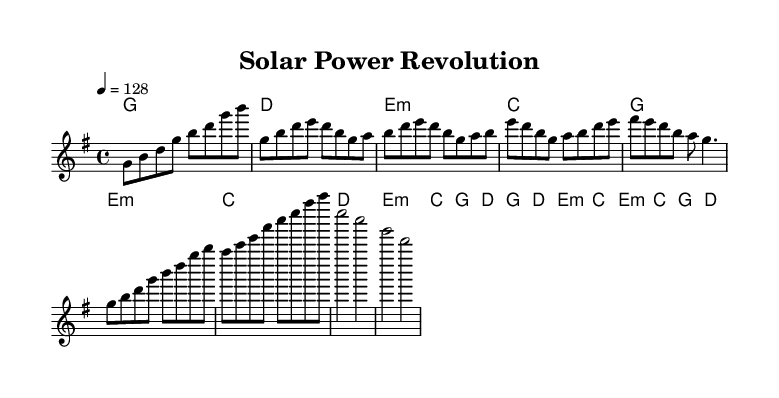What is the key signature of this music? The key signature is G major, which has one sharp (F#). This can be identified in the global settings at the beginning of the code, specifically within the key command.
Answer: G major What is the time signature of this music? The time signature is 4/4, which means there are four beats per measure and the quarter note gets one beat. This is indicated in the global settings of the code.
Answer: 4/4 What is the tempo marking for this piece? The tempo marking is 128 beats per minute. This is specified in the global settings with the tempo command.
Answer: 128 How many sections are there in the music? The music consists of five sections: Intro, Verse, Pre-Chorus, Chorus, and Bridge. Each of these sections can be identified in the melody and harmonic structure presented in the code.
Answer: Five What is the first lyric in the verse? The first lyric in the verse is "Sun." This can be found in the verseWords section, where the lyrics corresponding to the melody are provided.
Answer: Sun What energy source is most prominently referenced in the chorus? The energy source referenced in the chorus is "solar power." This is evident in the chorusWords section where the phrase repeatedly emphasizes its significance.
Answer: Solar power How do the lyrics in the pre-chorus relate to renewable energy? The pre-chorus lyrics mention "wind turbines," which directly relates to renewable energy sources, specifically wind energy. This demonstrates a connection to broader themes of sustainability in the lyrics.
Answer: Wind turbines 